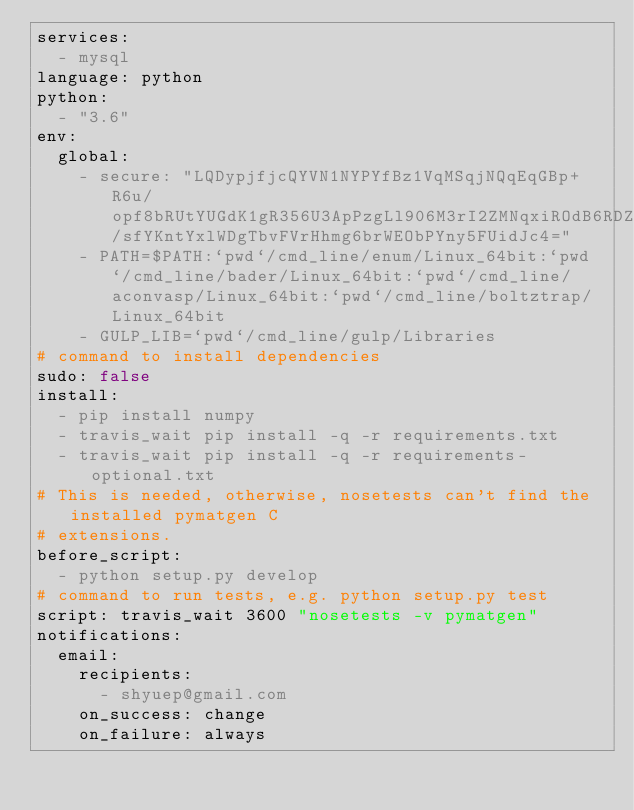Convert code to text. <code><loc_0><loc_0><loc_500><loc_500><_YAML_>services:
  - mysql
language: python
python:
  - "3.6"
env:
  global:
    - secure: "LQDypjfjcQYVN1NYPYfBz1VqMSqjNQqEqGBp+R6u/opf8bRUtYUGdK1gR356U3ApPzgLl906M3rI2ZMNqxiROdB6RDZrDEzXLhushwCfqt0C9qmZFLsj7TtGCMT8qHahU/sfYKntYxlWDgTbvFVrHhmg6brWEObPYny5FUidJc4="
    - PATH=$PATH:`pwd`/cmd_line/enum/Linux_64bit:`pwd`/cmd_line/bader/Linux_64bit:`pwd`/cmd_line/aconvasp/Linux_64bit:`pwd`/cmd_line/boltztrap/Linux_64bit
    - GULP_LIB=`pwd`/cmd_line/gulp/Libraries
# command to install dependencies
sudo: false
install:
  - pip install numpy
  - travis_wait pip install -q -r requirements.txt
  - travis_wait pip install -q -r requirements-optional.txt
# This is needed, otherwise, nosetests can't find the installed pymatgen C
# extensions.
before_script:
  - python setup.py develop
# command to run tests, e.g. python setup.py test
script: travis_wait 3600 "nosetests -v pymatgen"
notifications:
  email:
    recipients:
      - shyuep@gmail.com
    on_success: change
    on_failure: always
</code> 